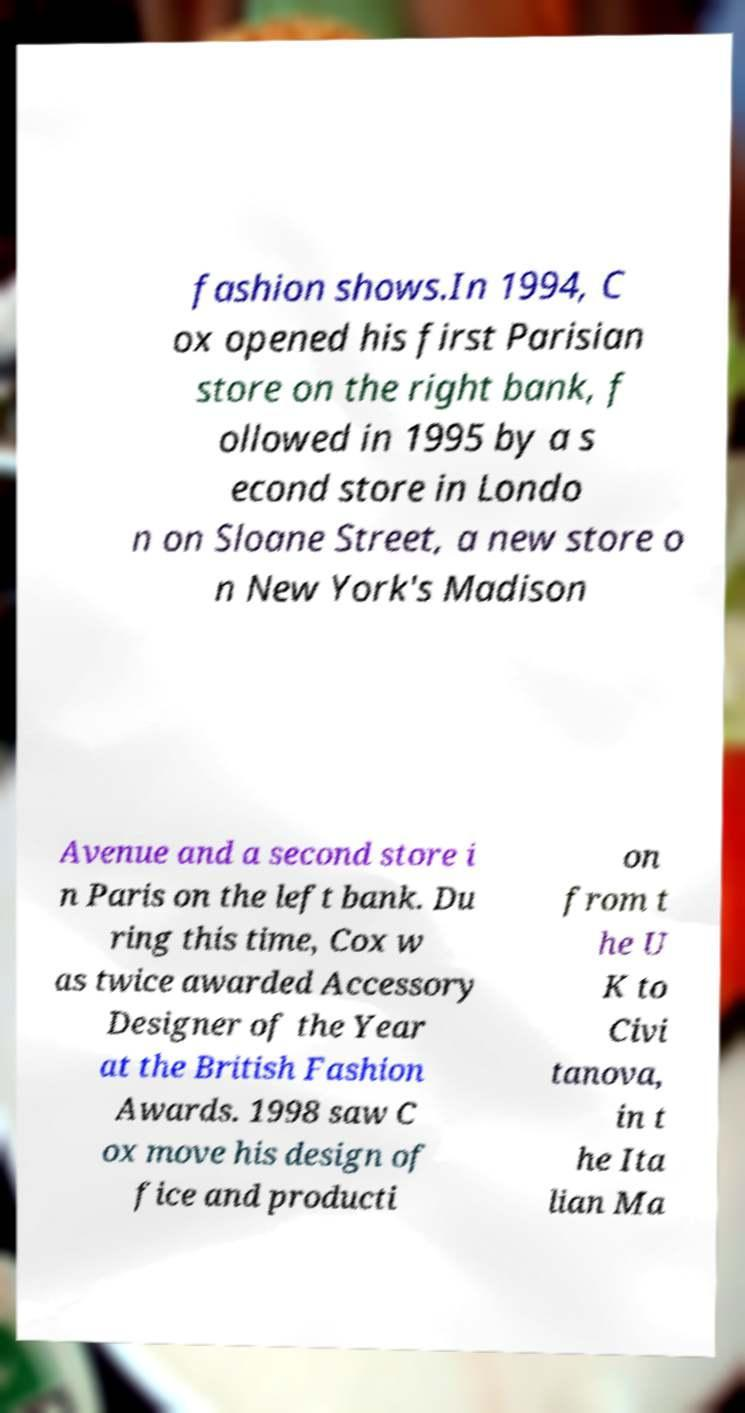There's text embedded in this image that I need extracted. Can you transcribe it verbatim? fashion shows.In 1994, C ox opened his first Parisian store on the right bank, f ollowed in 1995 by a s econd store in Londo n on Sloane Street, a new store o n New York's Madison Avenue and a second store i n Paris on the left bank. Du ring this time, Cox w as twice awarded Accessory Designer of the Year at the British Fashion Awards. 1998 saw C ox move his design of fice and producti on from t he U K to Civi tanova, in t he Ita lian Ma 